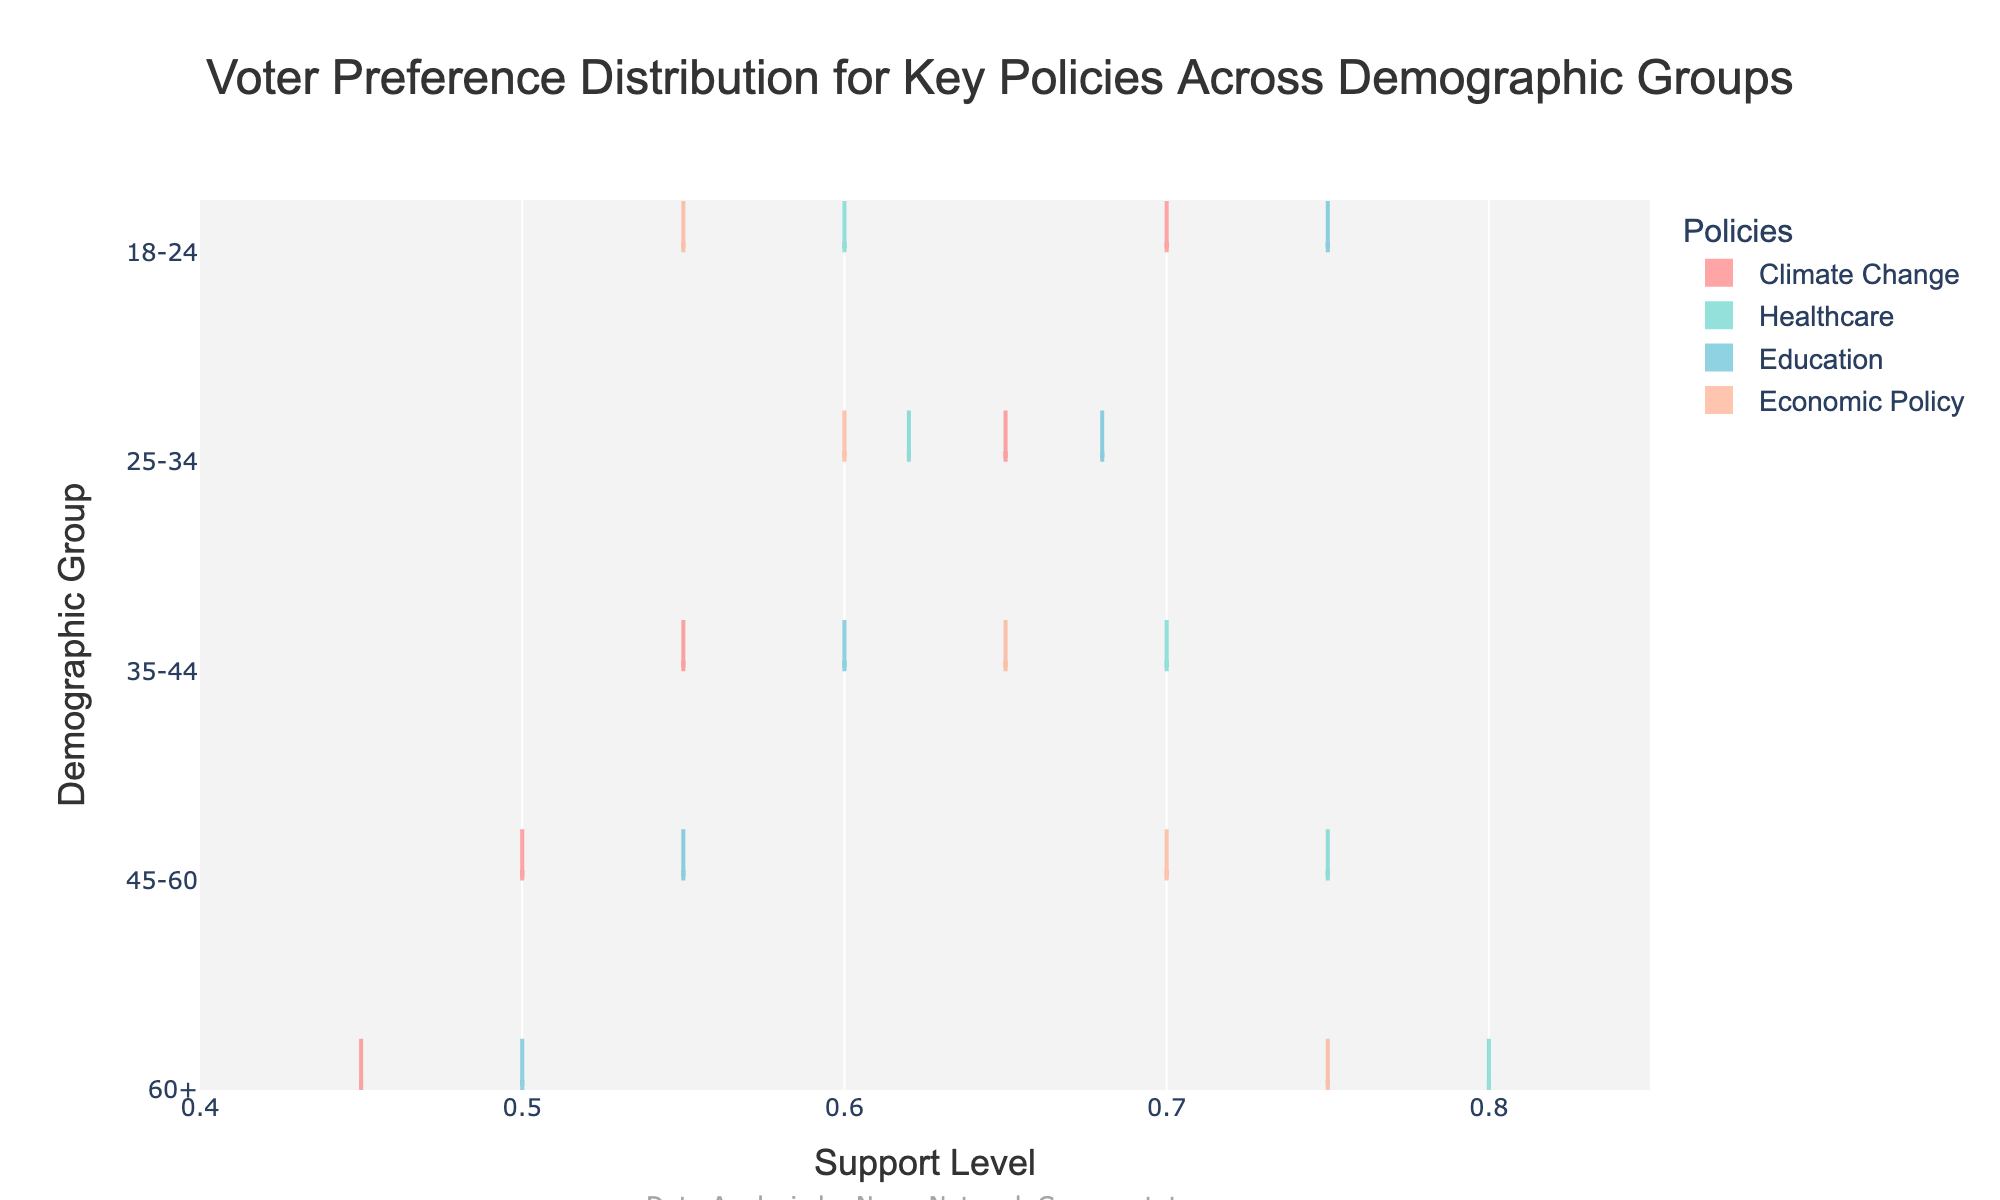What is the title of the plot? The title of the plot is typically written at the top of the figure. Here, it reads "Voter Preference Distribution for Key Policies Across Demographic Groups."
Answer: Voter Preference Distribution for Key Policies Across Demographic Groups What is the range of support levels displayed on the x-axis? The x-axis is labeled with 'Support Level' and marked with tick labels from 0.4 to 0.85. This indicates that the support levels range from 0.4 to 0.85.
Answer: 0.4 to 0.85 Which demographic group shows the highest support level for healthcare? To identify the highest support level for healthcare, look at the healthcare violin plot and check which demographic group's horizontal position extends furthest to the right. 60+ shows the highest support level at 0.80.
Answer: 60+ What is the average support level for climate change across all demographic groups? Add the support levels for climate change across all groups (0.70 + 0.65 + 0.55 + 0.50 + 0.45) and divide by 5: (0.70 + 0.65 + 0.55 + 0.50 + 0.45) / 5. The sum is 2.85 and the average is 2.85 / 5.
Answer: 0.57 Which demographic group has the smallest support level range in any of the policies displayed? To find the smallest range, observe the width of the violin plots for each group and policy. Here, each individual's range is the same since individual points aren't shown, but the violin width suggests the variability of each group. The 18-24 group shows fairly narrow bands except for education.
Answer: 18-24 Comparing the support level for healthcare between the 25-34 and 45-60 groups, which one is higher? Compare the support level of 0.62 for the 25-34 group and 0.75 for the 45-60 group. The 45-60 group has a higher support level.
Answer: 45-60 Is the support level for education more consistent within the 35-44 group or the 18-24 group? To check consistency, observe the spread of the violin plots for education for these groups. The 35-44 group’s violin appears narrower and more consistent compared to the 18-24 group.
Answer: 35-44 What pattern do you observe about the support for economic policy as the demographic groups age? Examining the economic policy violins, support levels appear to increase with age. Starting from 0.55 in the 18-24 group to 0.75 in the 60+ group.
Answer: Increases with age What is the trend in support for climate change from the 18-24 group to the 60+ group? Observe all five demographic groups for the climate change policy. The support level decreases from 0.70 in the 18-24 group to 0.45 in the 60+ group.
Answer: Decreases with age 